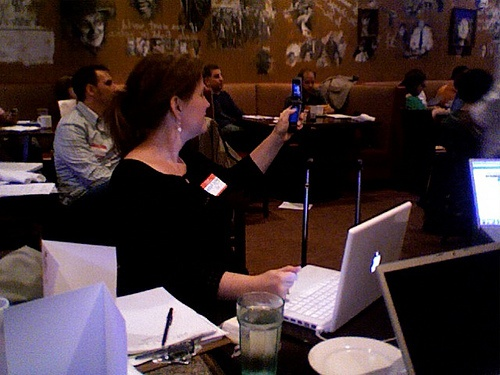Describe the objects in this image and their specific colors. I can see people in brown, black, and maroon tones, laptop in brown, black, gray, and maroon tones, dining table in brown, black, darkgray, gray, and lightgray tones, laptop in brown, lavender, purple, and black tones, and people in brown, black, gray, and maroon tones in this image. 